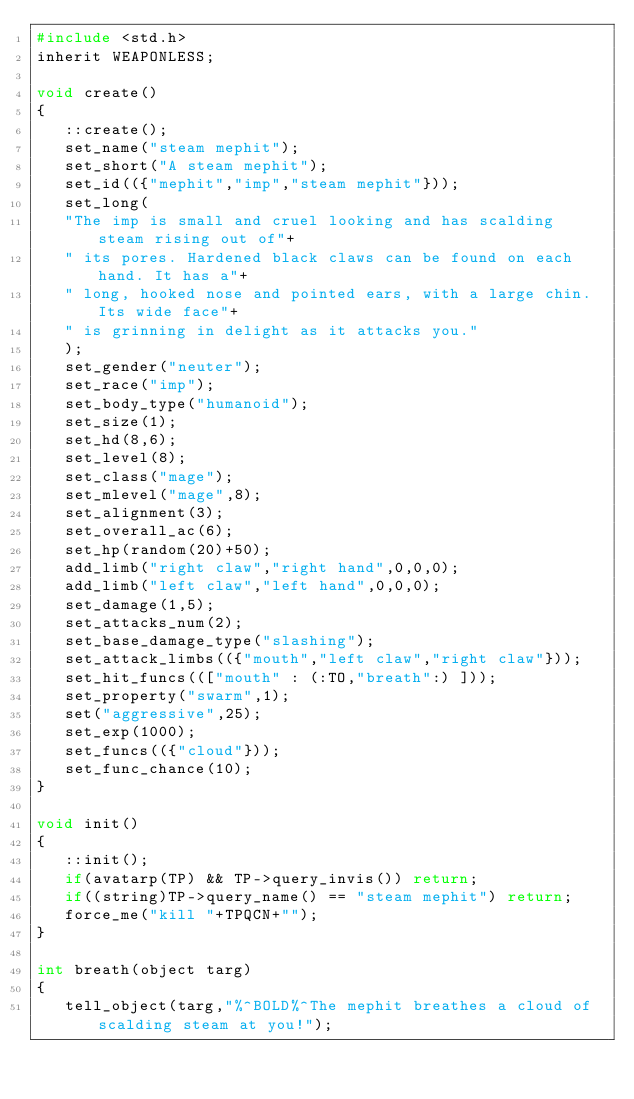<code> <loc_0><loc_0><loc_500><loc_500><_C_>#include <std.h>
inherit WEAPONLESS;

void create()
{
   ::create();
   set_name("steam mephit");
   set_short("A steam mephit");
   set_id(({"mephit","imp","steam mephit"}));
   set_long(
   "The imp is small and cruel looking and has scalding steam rising out of"+
   " its pores. Hardened black claws can be found on each hand. It has a"+
   " long, hooked nose and pointed ears, with a large chin. Its wide face"+
   " is grinning in delight as it attacks you."
   );
   set_gender("neuter");
   set_race("imp");
   set_body_type("humanoid");
   set_size(1);
   set_hd(8,6);
   set_level(8);
   set_class("mage");
   set_mlevel("mage",8);
   set_alignment(3);
   set_overall_ac(6);
   set_hp(random(20)+50);
   add_limb("right claw","right hand",0,0,0);
   add_limb("left claw","left hand",0,0,0);
   set_damage(1,5);
   set_attacks_num(2);
   set_base_damage_type("slashing");
   set_attack_limbs(({"mouth","left claw","right claw"}));
   set_hit_funcs((["mouth" : (:TO,"breath":) ]));
   set_property("swarm",1);
   set("aggressive",25);
   set_exp(1000);
   set_funcs(({"cloud"}));
   set_func_chance(10);
}

void init()
{
   ::init();
   if(avatarp(TP) && TP->query_invis()) return;
   if((string)TP->query_name() == "steam mephit") return;
   force_me("kill "+TPQCN+"");
}

int breath(object targ)
{
   tell_object(targ,"%^BOLD%^The mephit breathes a cloud of scalding steam at you!");</code> 